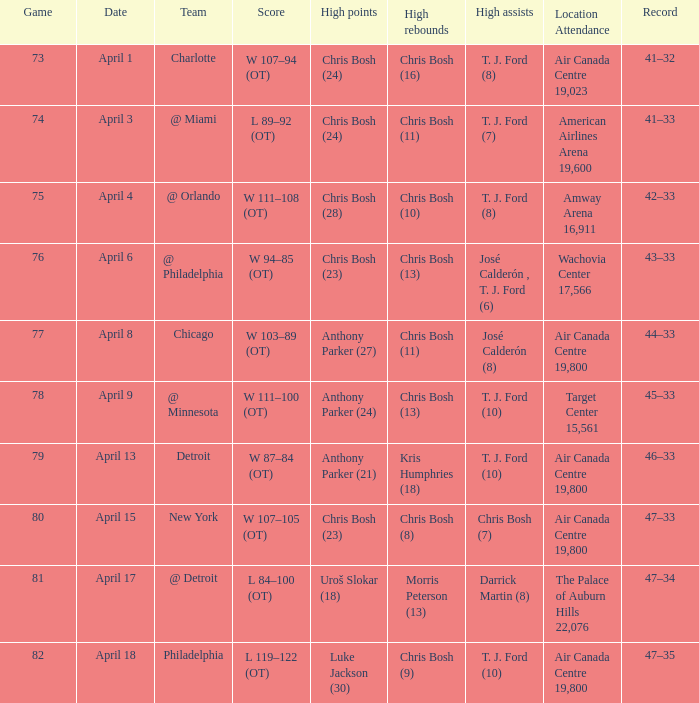What were the number of assists on april 8 in games with less than 78 points? José Calderón (8). 